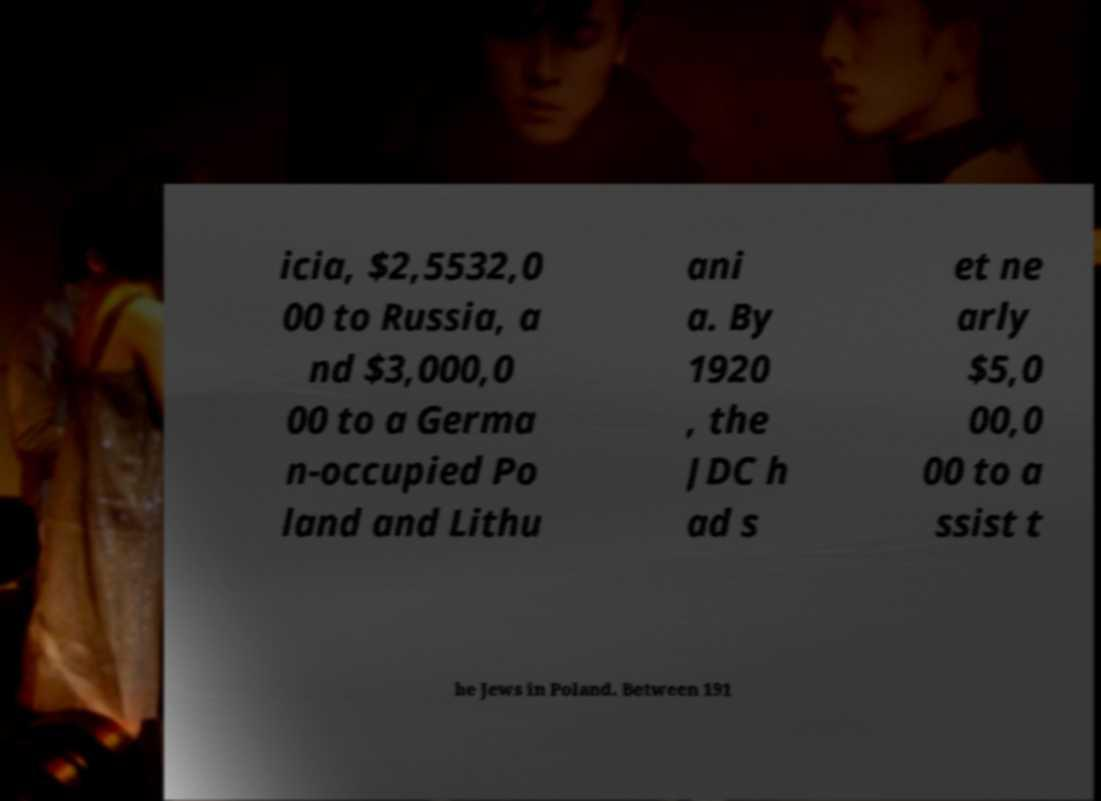For documentation purposes, I need the text within this image transcribed. Could you provide that? icia, $2,5532,0 00 to Russia, a nd $3,000,0 00 to a Germa n-occupied Po land and Lithu ani a. By 1920 , the JDC h ad s et ne arly $5,0 00,0 00 to a ssist t he Jews in Poland. Between 191 